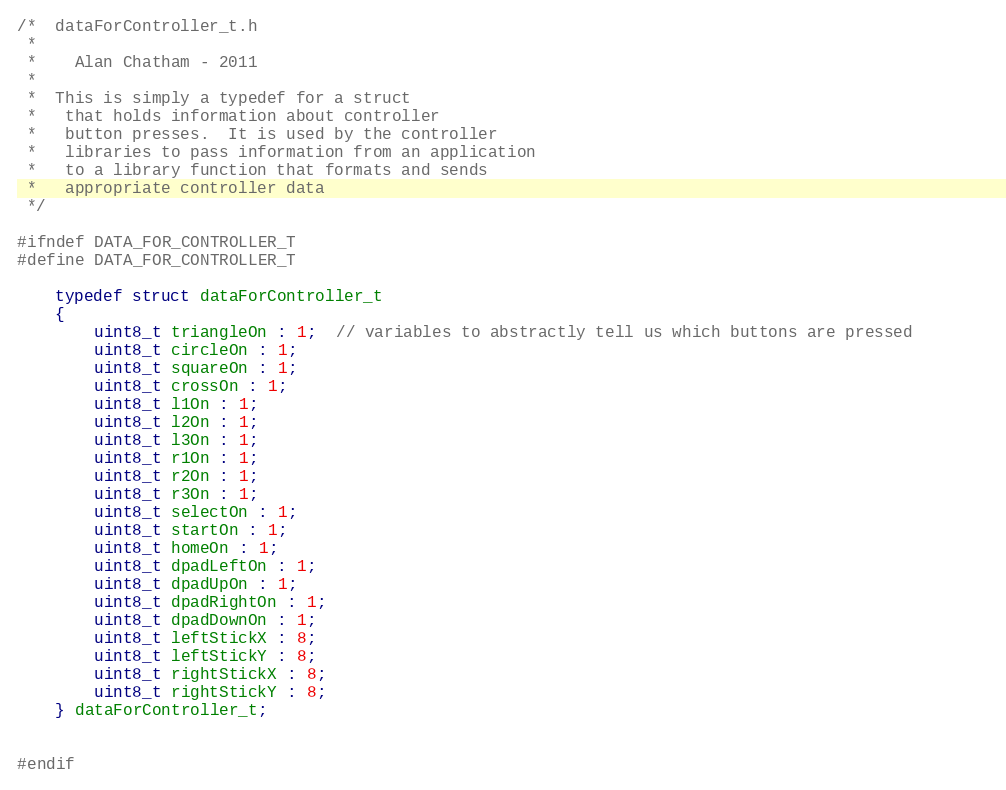Convert code to text. <code><loc_0><loc_0><loc_500><loc_500><_C_>/*  dataForController_t.h
 *
 *	  Alan Chatham - 2011
 *
 *  This is simply a typedef for a struct
 *   that holds information about controller
 *   button presses.  It is used by the controller
 *   libraries to pass information from an application
 *   to a library function that formats and sends
 *   appropriate controller data
 */

#ifndef DATA_FOR_CONTROLLER_T
#define DATA_FOR_CONTROLLER_T

	typedef struct dataForController_t
	{
		uint8_t triangleOn : 1;  // variables to abstractly tell us which buttons are pressed		
		uint8_t circleOn : 1;
		uint8_t squareOn : 1;
		uint8_t crossOn : 1;
		uint8_t l1On : 1;
		uint8_t l2On : 1;
		uint8_t l3On : 1;
		uint8_t r1On : 1;
		uint8_t r2On : 1;
		uint8_t r3On : 1;
		uint8_t selectOn : 1;
		uint8_t startOn : 1;
		uint8_t homeOn : 1;
		uint8_t dpadLeftOn : 1;
		uint8_t dpadUpOn : 1;
		uint8_t dpadRightOn : 1;
		uint8_t dpadDownOn : 1;
		uint8_t leftStickX : 8; 
		uint8_t leftStickY : 8;
		uint8_t rightStickX : 8;
		uint8_t rightStickY : 8;
	} dataForController_t;


#endif
</code> 